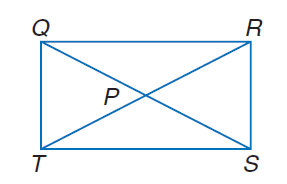Answer the mathemtical geometry problem and directly provide the correct option letter.
Question: Q R S T is a rectangle. If Q P = 3 x + 11 and P S = 4 x + 8, find Q S.
Choices: A: 10 B: 20 C: 25 D: 40 D 